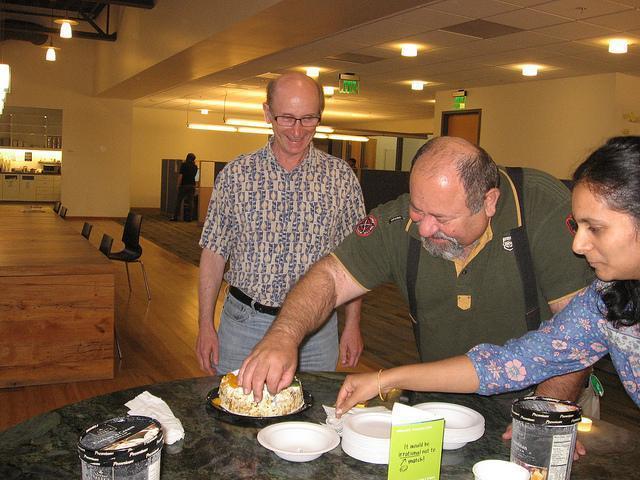How many ice cream containers are there?
Give a very brief answer. 2. How many people are there?
Give a very brief answer. 3. How many dining tables are in the picture?
Give a very brief answer. 2. 